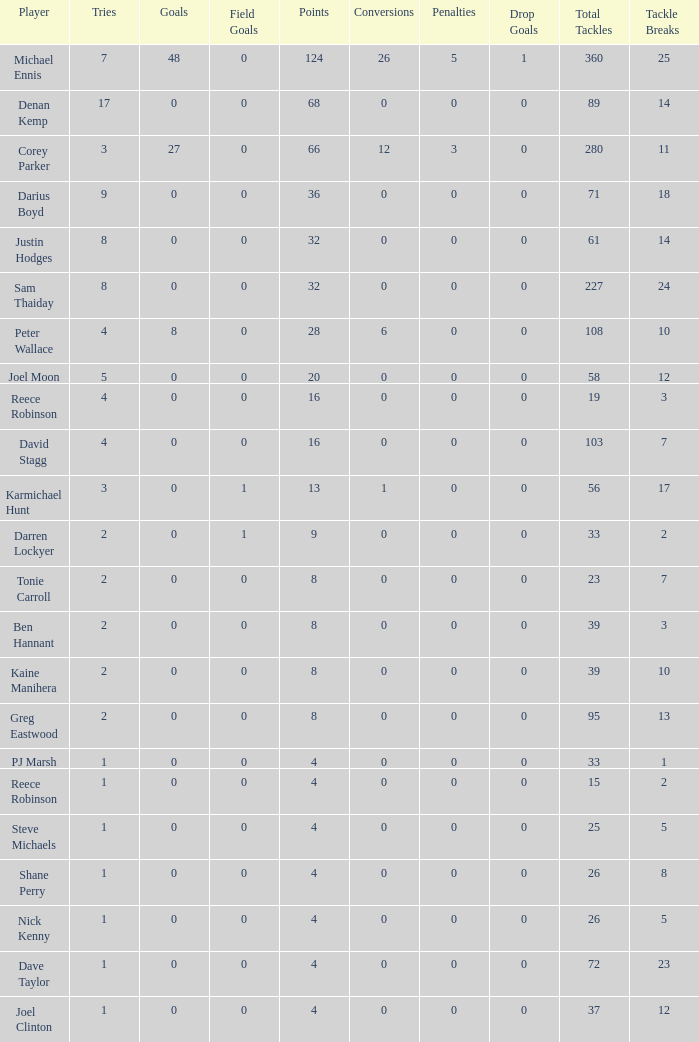How many goals did the player with less than 4 points have? 0.0. Write the full table. {'header': ['Player', 'Tries', 'Goals', 'Field Goals', 'Points', 'Conversions', 'Penalties', 'Drop Goals', 'Total Tackles', 'Tackle Breaks '], 'rows': [['Michael Ennis', '7', '48', '0', '124', '26', '5', '1', '360', '25'], ['Denan Kemp', '17', '0', '0', '68', '0', '0', '0', '89', '14'], ['Corey Parker', '3', '27', '0', '66', '12', '3', '0', '280', '11'], ['Darius Boyd', '9', '0', '0', '36', '0', '0', '0', '71', '18'], ['Justin Hodges', '8', '0', '0', '32', '0', '0', '0', '61', '14'], ['Sam Thaiday', '8', '0', '0', '32', '0', '0', '0', '227', '24'], ['Peter Wallace', '4', '8', '0', '28', '6', '0', '0', '108', '10'], ['Joel Moon', '5', '0', '0', '20', '0', '0', '0', '58', '12'], ['Reece Robinson', '4', '0', '0', '16', '0', '0', '0', '19', '3'], ['David Stagg', '4', '0', '0', '16', '0', '0', '0', '103', '7'], ['Karmichael Hunt', '3', '0', '1', '13', '1', '0', '0', '56', '17'], ['Darren Lockyer', '2', '0', '1', '9', '0', '0', '0', '33', '2'], ['Tonie Carroll', '2', '0', '0', '8', '0', '0', '0', '23', '7'], ['Ben Hannant', '2', '0', '0', '8', '0', '0', '0', '39', '3'], ['Kaine Manihera', '2', '0', '0', '8', '0', '0', '0', '39', '10'], ['Greg Eastwood', '2', '0', '0', '8', '0', '0', '0', '95', '13'], ['PJ Marsh', '1', '0', '0', '4', '0', '0', '0', '33', '1'], ['Reece Robinson', '1', '0', '0', '4', '0', '0', '0', '15', '2'], ['Steve Michaels', '1', '0', '0', '4', '0', '0', '0', '25', '5'], ['Shane Perry', '1', '0', '0', '4', '0', '0', '0', '26', '8'], ['Nick Kenny', '1', '0', '0', '4', '0', '0', '0', '26', '5'], ['Dave Taylor', '1', '0', '0', '4', '0', '0', '0', '72', '23'], ['Joel Clinton', '1', '0', '0', '4', '0', '0', '0', '37', '12']]} 